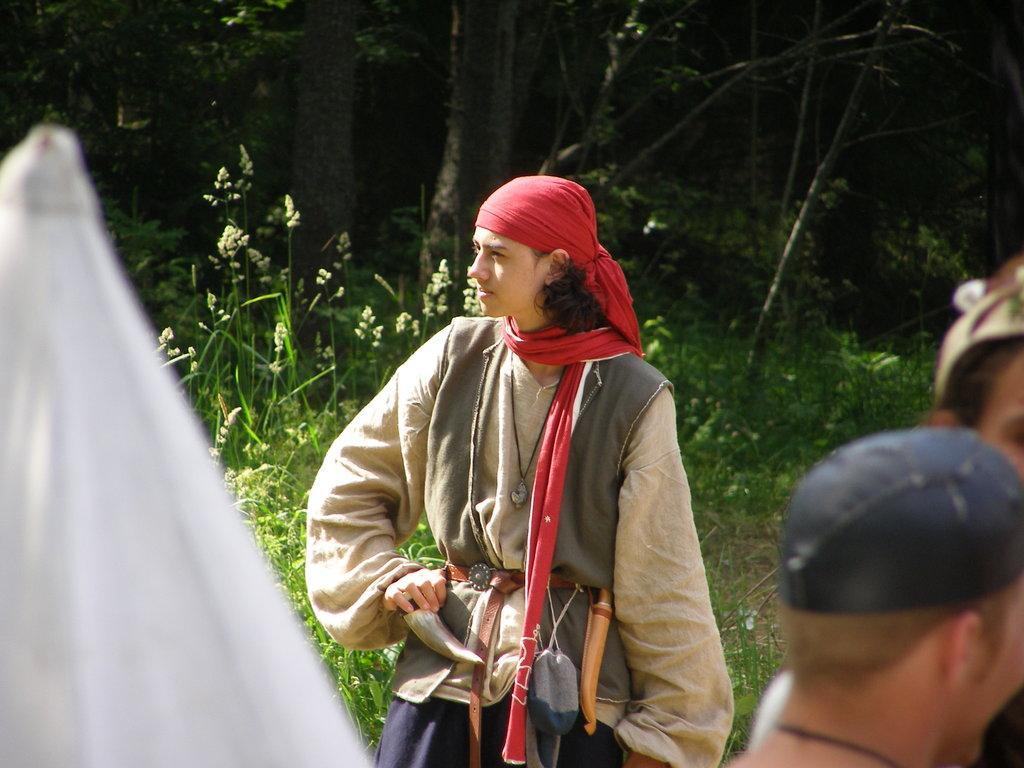Could you give a brief overview of what you see in this image? In this image, we can see a person is standing. On the left side of the image, we can see a white color object. Background we can see plants and trees. On the right side bottom corner, we can see people. 